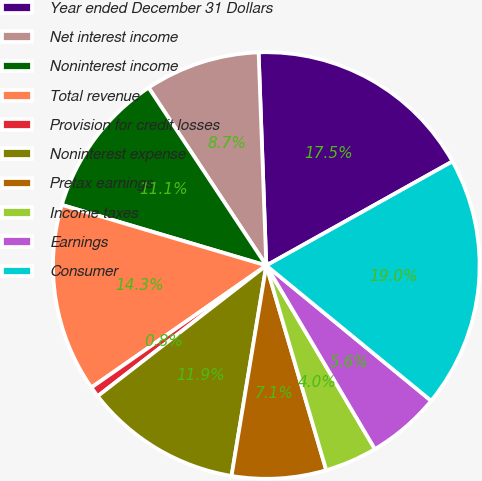<chart> <loc_0><loc_0><loc_500><loc_500><pie_chart><fcel>Year ended December 31 Dollars<fcel>Net interest income<fcel>Noninterest income<fcel>Total revenue<fcel>Provision for credit losses<fcel>Noninterest expense<fcel>Pretax earnings<fcel>Income taxes<fcel>Earnings<fcel>Consumer<nl><fcel>17.46%<fcel>8.73%<fcel>11.11%<fcel>14.28%<fcel>0.8%<fcel>11.9%<fcel>7.14%<fcel>3.97%<fcel>5.56%<fcel>19.05%<nl></chart> 